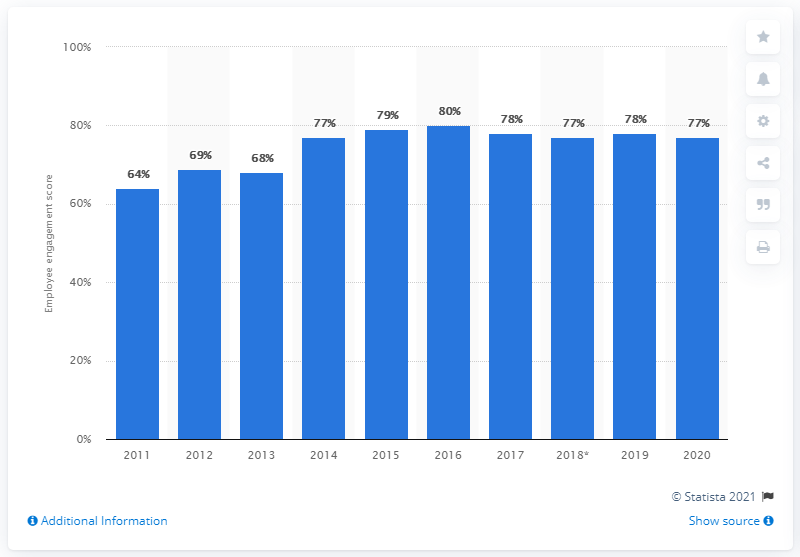List a handful of essential elements in this visual. In 2020, the employee engagement score of Nationwide Building Society was 77%. In 2016, the largest employee engagement score was found. 